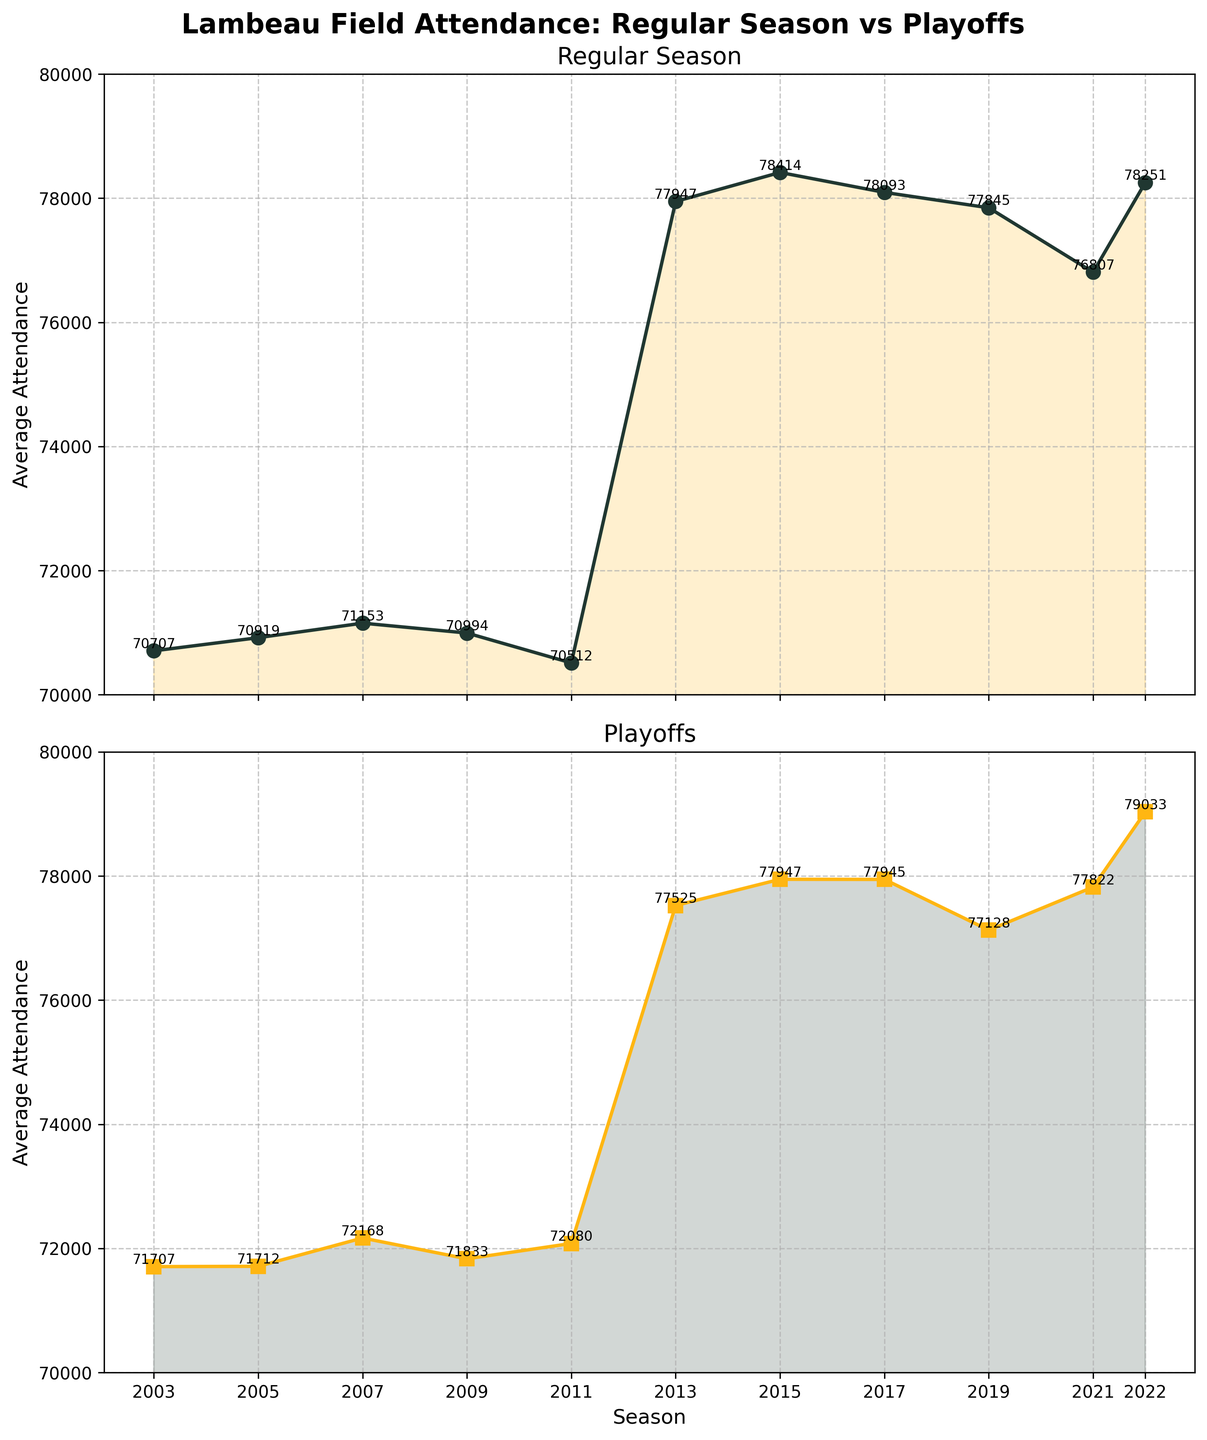What's the title of the figure? The title is written at the top of the figure, typically in a larger and bolder font. It reads, "Lambeau Field Attendance: Regular Season vs Playoffs".
Answer: Lambeau Field Attendance: Regular Season vs Playoffs What years are covered in the figure? The x-axis displays the seasons, which can be read from left to right. The first season shown is 2003 and the last one is 2022.
Answer: 2003 to 2022 Which season had the highest average attendance for regular season games? By looking at the line plot in the top subplot, the peak of the green line corresponds to the 2015 season. The annotated value confirms it.
Answer: 2015 How do the attendance values compare between regular season and playoff games in the 2011 season? Find the 2011 point on both subplots. The regular season subplot has an average attendance value of 70512, while the playoff subplot has a value of 72080. Comparatively, playoff attendance is higher than regular season attendance in 2011.
Answer: Playoff is higher What's the difference in average attendance between regular season and playoff games in 2022? Take the values from both subplots for the year 2022: regular season is 78251 and playoff is 79033. Subtracting these gives 79033 - 78251.
Answer: 782 Which subplot shows the average attendance for playoff games? The titles of the subplots distinguish them. The bottom subplot has the title "Playoffs" indicating it shows the average playoff attendance.
Answer: Bottom subplot What trend do you observe in regular season attendance over the last 20 seasons? Viewing the top subplot, there's a general increasing trend in regular season attendance with minor fluctuations, particularly starting lower around 2003 and peaking around 2015 before slightly decreasing.
Answer: Increasing with fluctuations In which season were the playoff average attendance figures the closest to regular season figures? By comparing the values visually from both subplots, the closest values occur in 2013, with regular season attendance at 77947 and playoff attendance at 77525.
Answer: 2013 What's the average attendance for regular season games in 2007? Locate the value on the top subplot at the 2007 position. The annotated value is 71153.
Answer: 71153 